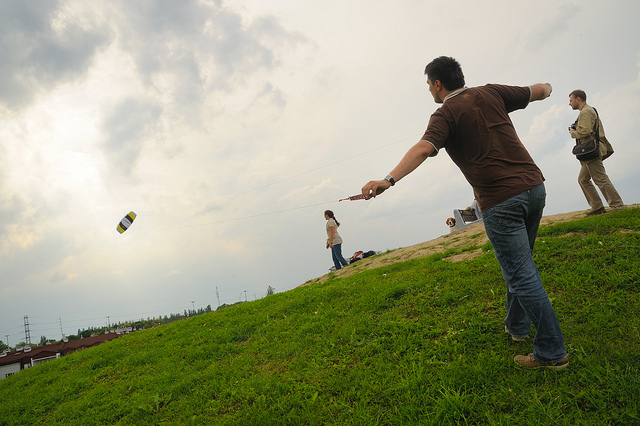Describe the setting of this photo. The photo is set in an open field that has a gentle incline. The sky is overcast, suggesting it could be a breezy day, which is ideal for outdoor activities like flying kites. In the background, infrastructure like power lines and buildings are visible, indicating the proximity to a residential area. 